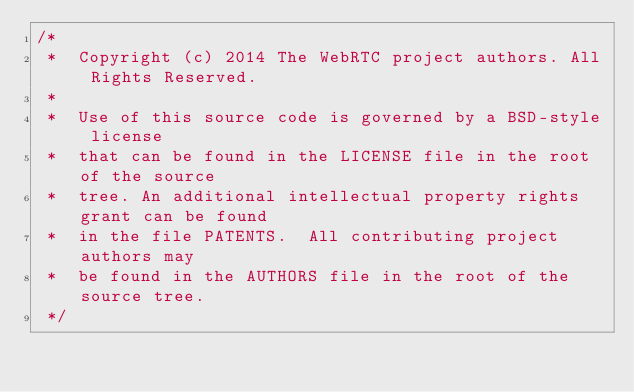<code> <loc_0><loc_0><loc_500><loc_500><_C++_>/*
 *  Copyright (c) 2014 The WebRTC project authors. All Rights Reserved.
 *
 *  Use of this source code is governed by a BSD-style license
 *  that can be found in the LICENSE file in the root of the source
 *  tree. An additional intellectual property rights grant can be found
 *  in the file PATENTS.  All contributing project authors may
 *  be found in the AUTHORS file in the root of the source tree.
 */
</code> 